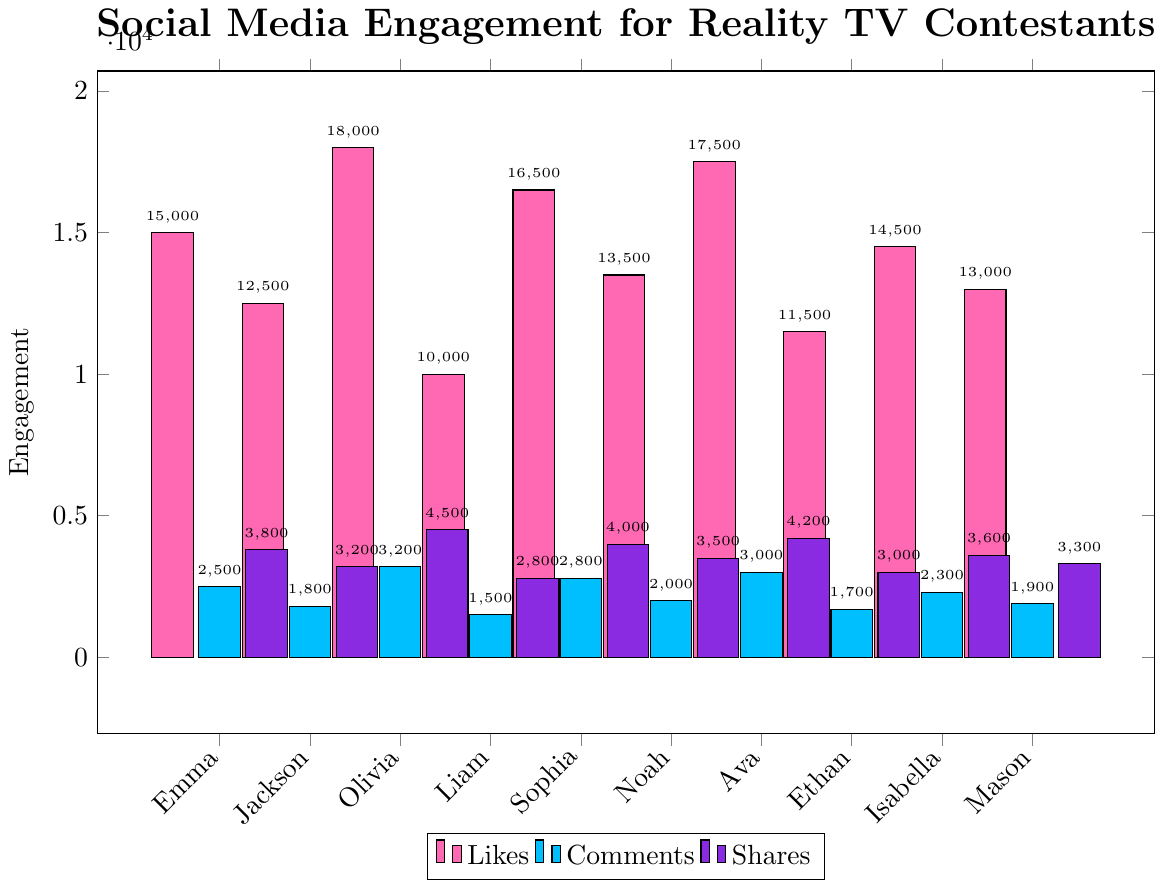Which contestant received the highest number of likes? Observe the "Likes" bars. Identify the tallest bar under "Likes," which corresponds to Olivia with 18,000 likes.
Answer: Olivia Who received more comments, Emma or Mason? Compare the heights of the "Comments" bars for Emma and Mason. Emma’s bar is higher than Mason’s.
Answer: Emma What is the sum of likes for Olivia and Ava? Sum the likes for Olivia (18,000) and Ava (17,500). 18,000 + 17,500 = 35,500.
Answer: 35,500 Which contestant has the fewest shares? Identify the shortest bar under "Shares." The shortest bar corresponds to Liam with 2,800 shares.
Answer: Liam Who has more overall engagement in terms of likes and shares combined: Ethan or Mason? Sum the likes and shares for Ethan (11,500 + 3,000) and Mason (13,000 + 3,300). Ethan: 14,500; Mason: 16,300. Mason has more overall engagement.
Answer: Mason What is the difference in the number of shares between Sophia and Isabella? Subtract Isabella's shares (3,600) from Sophia's shares (4,000). 4,000 - 3,600 = 400.
Answer: 400 Which contestant has the second highest number of comments? Rank the "Comments" bars from highest to lowest. The second highest bar corresponds to Ava with 3,000 comments.
Answer: Ava Is the combined number of comments and shares for Jackson greater than the total comments for Noah? Calculate the combined comments and shares for Jackson (1,800 + 3,200) and compare to Noah's comments (2,000). Combined for Jackson: 5,000. Jackson's combined number is greater than Noah’s comments.
Answer: Yes Which contestant has more likes, Jackson or Noah? Compare the heights of the "Likes" bars for Jackson and Noah. Noah's bar is taller than Jackson's.
Answer: Noah What is the average number of shares among all the contestants? Sum all shares: 3,800 + 3,200 + 4,500 + 2,800 + 4,000 + 3,500 + 4,200 + 3,000 + 3,600 + 3,300 = 35,900. Divide by the number of contestants (10). Average: 35,900 / 10 = 3,590.
Answer: 3,590 